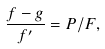Convert formula to latex. <formula><loc_0><loc_0><loc_500><loc_500>\frac { f - g } { f ^ { \prime } } = P / F ,</formula> 